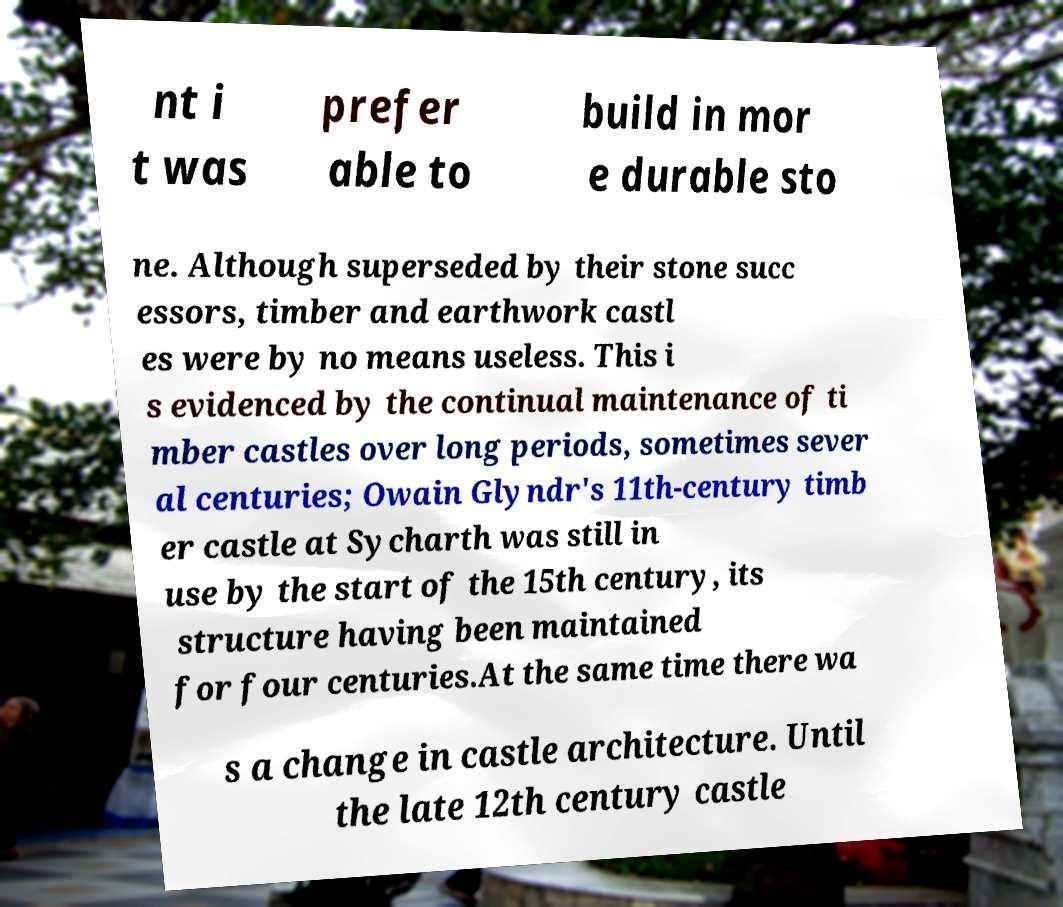Can you accurately transcribe the text from the provided image for me? nt i t was prefer able to build in mor e durable sto ne. Although superseded by their stone succ essors, timber and earthwork castl es were by no means useless. This i s evidenced by the continual maintenance of ti mber castles over long periods, sometimes sever al centuries; Owain Glyndr's 11th-century timb er castle at Sycharth was still in use by the start of the 15th century, its structure having been maintained for four centuries.At the same time there wa s a change in castle architecture. Until the late 12th century castle 